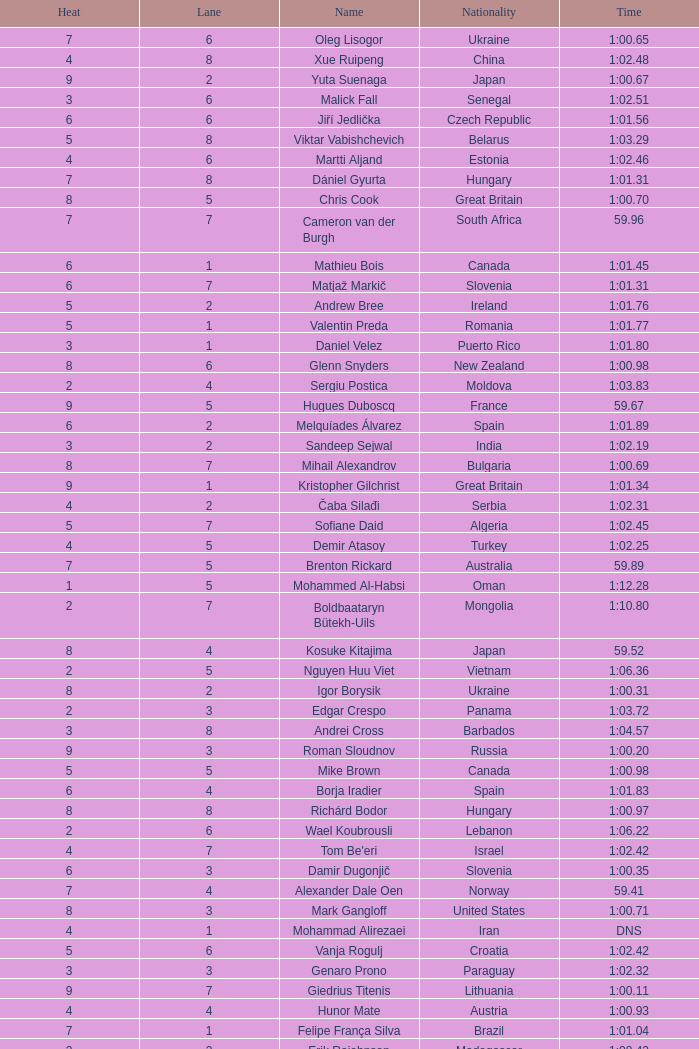Write the full table. {'header': ['Heat', 'Lane', 'Name', 'Nationality', 'Time'], 'rows': [['7', '6', 'Oleg Lisogor', 'Ukraine', '1:00.65'], ['4', '8', 'Xue Ruipeng', 'China', '1:02.48'], ['9', '2', 'Yuta Suenaga', 'Japan', '1:00.67'], ['3', '6', 'Malick Fall', 'Senegal', '1:02.51'], ['6', '6', 'Jiří Jedlička', 'Czech Republic', '1:01.56'], ['5', '8', 'Viktar Vabishchevich', 'Belarus', '1:03.29'], ['4', '6', 'Martti Aljand', 'Estonia', '1:02.46'], ['7', '8', 'Dániel Gyurta', 'Hungary', '1:01.31'], ['8', '5', 'Chris Cook', 'Great Britain', '1:00.70'], ['7', '7', 'Cameron van der Burgh', 'South Africa', '59.96'], ['6', '1', 'Mathieu Bois', 'Canada', '1:01.45'], ['6', '7', 'Matjaž Markič', 'Slovenia', '1:01.31'], ['5', '2', 'Andrew Bree', 'Ireland', '1:01.76'], ['5', '1', 'Valentin Preda', 'Romania', '1:01.77'], ['3', '1', 'Daniel Velez', 'Puerto Rico', '1:01.80'], ['8', '6', 'Glenn Snyders', 'New Zealand', '1:00.98'], ['2', '4', 'Sergiu Postica', 'Moldova', '1:03.83'], ['9', '5', 'Hugues Duboscq', 'France', '59.67'], ['6', '2', 'Melquíades Álvarez', 'Spain', '1:01.89'], ['3', '2', 'Sandeep Sejwal', 'India', '1:02.19'], ['8', '7', 'Mihail Alexandrov', 'Bulgaria', '1:00.69'], ['9', '1', 'Kristopher Gilchrist', 'Great Britain', '1:01.34'], ['4', '2', 'Čaba Silađi', 'Serbia', '1:02.31'], ['5', '7', 'Sofiane Daid', 'Algeria', '1:02.45'], ['4', '5', 'Demir Atasoy', 'Turkey', '1:02.25'], ['7', '5', 'Brenton Rickard', 'Australia', '59.89'], ['1', '5', 'Mohammed Al-Habsi', 'Oman', '1:12.28'], ['2', '7', 'Boldbaataryn Bütekh-Uils', 'Mongolia', '1:10.80'], ['8', '4', 'Kosuke Kitajima', 'Japan', '59.52'], ['2', '5', 'Nguyen Huu Viet', 'Vietnam', '1:06.36'], ['8', '2', 'Igor Borysik', 'Ukraine', '1:00.31'], ['2', '3', 'Edgar Crespo', 'Panama', '1:03.72'], ['3', '8', 'Andrei Cross', 'Barbados', '1:04.57'], ['9', '3', 'Roman Sloudnov', 'Russia', '1:00.20'], ['5', '5', 'Mike Brown', 'Canada', '1:00.98'], ['6', '4', 'Borja Iradier', 'Spain', '1:01.83'], ['8', '8', 'Richárd Bodor', 'Hungary', '1:00.97'], ['2', '6', 'Wael Koubrousli', 'Lebanon', '1:06.22'], ['4', '7', "Tom Be'eri", 'Israel', '1:02.42'], ['6', '3', 'Damir Dugonjič', 'Slovenia', '1:00.35'], ['7', '4', 'Alexander Dale Oen', 'Norway', '59.41'], ['8', '3', 'Mark Gangloff', 'United States', '1:00.71'], ['4', '1', 'Mohammad Alirezaei', 'Iran', 'DNS'], ['5', '6', 'Vanja Rogulj', 'Croatia', '1:02.42'], ['3', '3', 'Genaro Prono', 'Paraguay', '1:02.32'], ['9', '7', 'Giedrius Titenis', 'Lithuania', '1:00.11'], ['4', '4', 'Hunor Mate', 'Austria', '1:00.93'], ['7', '1', 'Felipe França Silva', 'Brazil', '1:01.04'], ['2', '2', 'Erik Rajohnson', 'Madagascar', '1:08.42'], ['9', '6', 'Romanos Alyfantis', 'Greece', '1:03.39'], ['1', '4', 'Osama Mohammed Ye Alarag', 'Qatar', '1:10.83'], ['9', '8', 'Thijs van Valkengoed', 'Netherlands', '1:01.32'], ['5', '4', 'Yevgeniy Ryzhkov', 'Kazakhstan', '1:01.83'], ['3', '7', 'Ivan Demyanenko', 'Uzbekistan', '1:05.14'], ['6', '5', 'Vladislav Polyakov', 'Kazakhstan', '1:00.80'], ['1', '3', 'Petero Okotai', 'Cook Islands', '1:20.20'], ['7', '2', 'Henrique Barbosa', 'Brazil', '1:01.11'], ['4', '3', 'Jakob Jóhann Sveinsson', 'Iceland', '1:02.50'], ['3', '4', 'Sergio Andres Ferreyra', 'Argentina', '1:03.65'], ['9', '4', 'Brendan Hansen', 'United States', '1:00.65'], ['8', '1', 'Dmitry Komornikov', 'Russia', '1:01.82'], ['7', '3', 'Christian Sprenger', 'Australia', '1:00.36'], ['3', '5', 'Alwin de Prins', 'Luxembourg', '1:03.64'], ['5', '3', 'Jonas Andersson', 'Sweden', '1:01.77'], ['6', '8', 'Alessandro Terrin', 'Italy', 'DSQ']]} What is the smallest lane number of Xue Ruipeng? 8.0. 